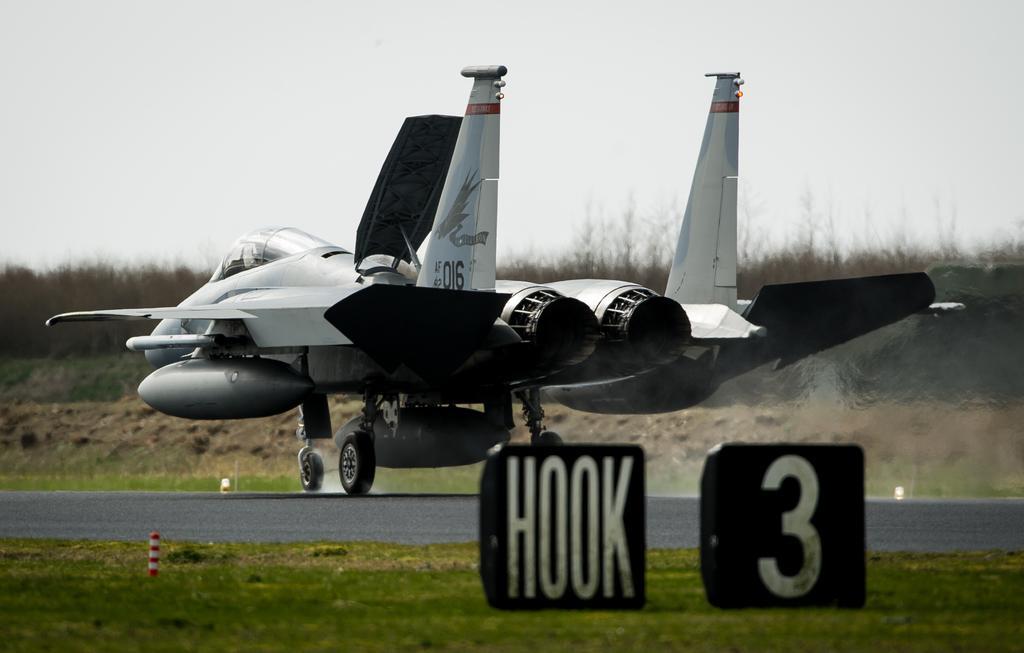Could you give a brief overview of what you see in this image? In this image I can see an aircraft on the road. To the side of the road I can see the black color boards and the traffic pole on the grass. In the background I can see the dried grass and the sky. 